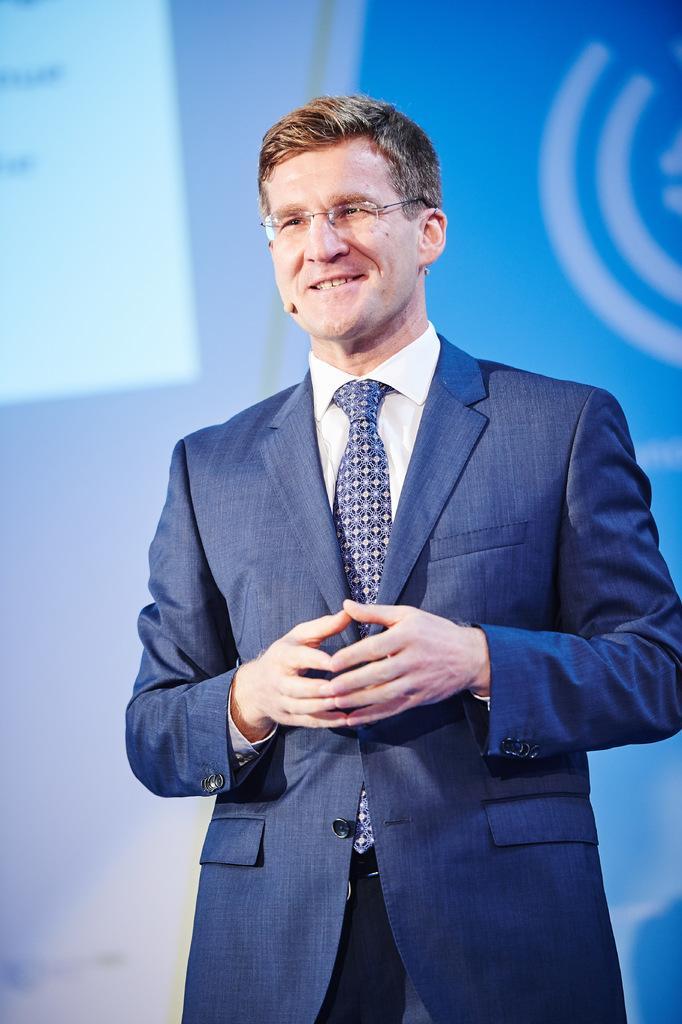Please provide a concise description of this image. In this picture there is a man who is wearing spectacle, mic, suit and trouser. Behind him we can see the projector screen. 